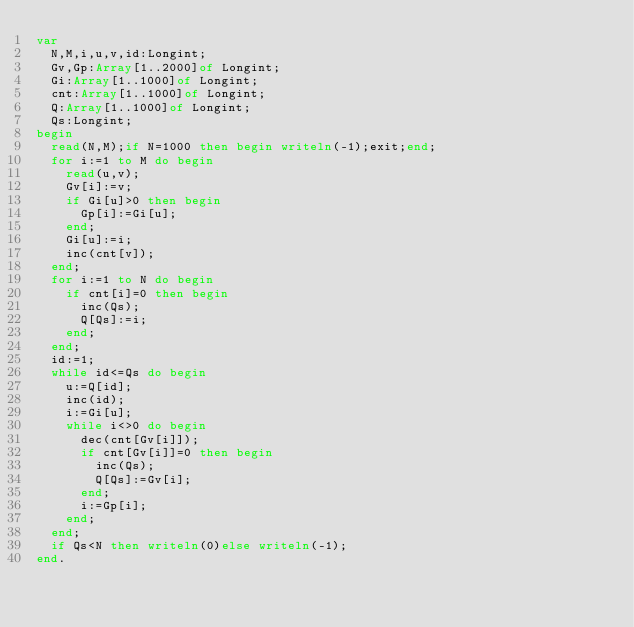Convert code to text. <code><loc_0><loc_0><loc_500><loc_500><_Pascal_>var
	N,M,i,u,v,id:Longint;
	Gv,Gp:Array[1..2000]of Longint;
	Gi:Array[1..1000]of Longint;
	cnt:Array[1..1000]of Longint;
	Q:Array[1..1000]of Longint;
	Qs:Longint;
begin
	read(N,M);if N=1000 then begin writeln(-1);exit;end;
	for i:=1 to M do begin
		read(u,v);
		Gv[i]:=v;
		if Gi[u]>0 then begin
			Gp[i]:=Gi[u];
		end;
		Gi[u]:=i;
		inc(cnt[v]);
	end;
	for i:=1 to N do begin
		if cnt[i]=0 then begin
			inc(Qs);
			Q[Qs]:=i;
		end;
	end;
	id:=1;
	while id<=Qs do begin
		u:=Q[id];
		inc(id);
		i:=Gi[u];
		while i<>0 do begin
			dec(cnt[Gv[i]]);
			if cnt[Gv[i]]=0 then begin
				inc(Qs);
				Q[Qs]:=Gv[i];
			end;
			i:=Gp[i];
		end;
	end;
	if Qs<N then writeln(0)else writeln(-1);
end.</code> 